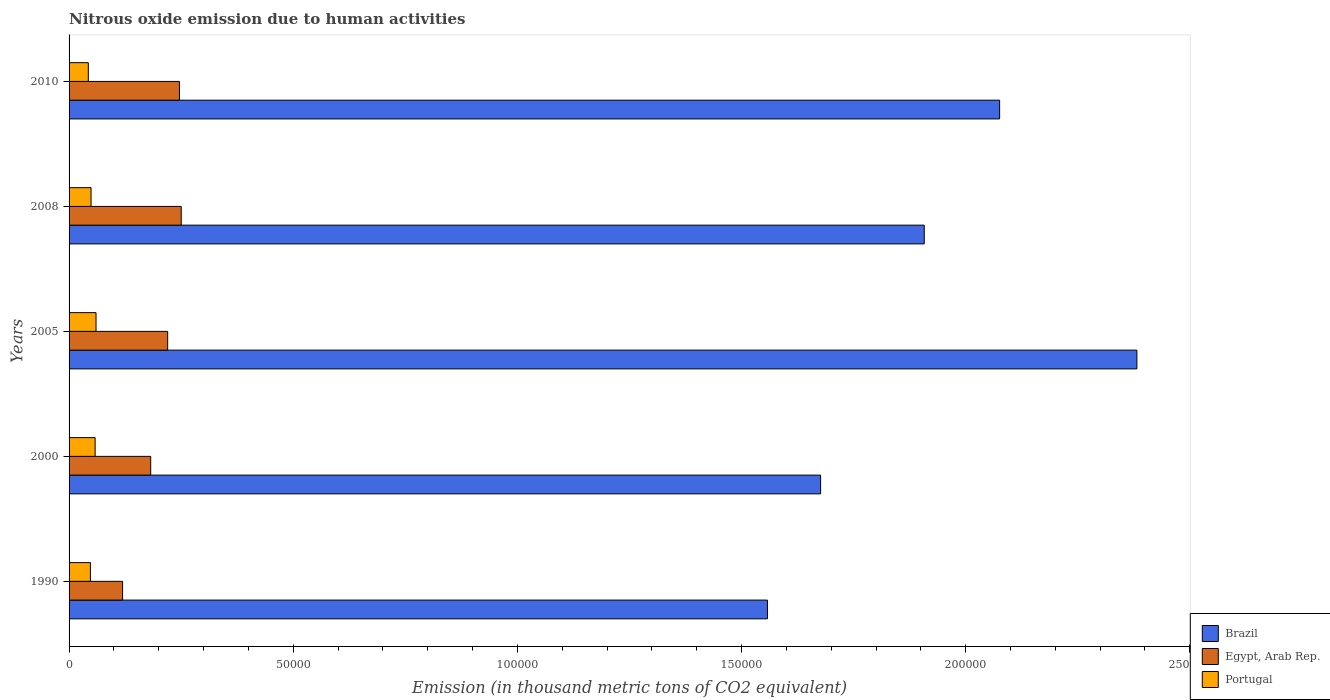Are the number of bars per tick equal to the number of legend labels?
Offer a very short reply. Yes. Are the number of bars on each tick of the Y-axis equal?
Your response must be concise. Yes. How many bars are there on the 4th tick from the bottom?
Your answer should be compact. 3. What is the amount of nitrous oxide emitted in Egypt, Arab Rep. in 2000?
Your answer should be compact. 1.82e+04. Across all years, what is the maximum amount of nitrous oxide emitted in Egypt, Arab Rep.?
Keep it short and to the point. 2.50e+04. Across all years, what is the minimum amount of nitrous oxide emitted in Brazil?
Offer a very short reply. 1.56e+05. In which year was the amount of nitrous oxide emitted in Brazil maximum?
Offer a terse response. 2005. In which year was the amount of nitrous oxide emitted in Brazil minimum?
Your answer should be compact. 1990. What is the total amount of nitrous oxide emitted in Portugal in the graph?
Your answer should be compact. 2.58e+04. What is the difference between the amount of nitrous oxide emitted in Brazil in 1990 and that in 2005?
Give a very brief answer. -8.24e+04. What is the difference between the amount of nitrous oxide emitted in Portugal in 2005 and the amount of nitrous oxide emitted in Egypt, Arab Rep. in 2008?
Ensure brevity in your answer.  -1.90e+04. What is the average amount of nitrous oxide emitted in Egypt, Arab Rep. per year?
Keep it short and to the point. 2.04e+04. In the year 1990, what is the difference between the amount of nitrous oxide emitted in Portugal and amount of nitrous oxide emitted in Egypt, Arab Rep.?
Ensure brevity in your answer.  -7176.1. In how many years, is the amount of nitrous oxide emitted in Portugal greater than 130000 thousand metric tons?
Give a very brief answer. 0. What is the ratio of the amount of nitrous oxide emitted in Portugal in 2005 to that in 2010?
Your response must be concise. 1.4. Is the amount of nitrous oxide emitted in Brazil in 2000 less than that in 2010?
Your answer should be compact. Yes. What is the difference between the highest and the second highest amount of nitrous oxide emitted in Brazil?
Your answer should be very brief. 3.06e+04. What is the difference between the highest and the lowest amount of nitrous oxide emitted in Egypt, Arab Rep.?
Your response must be concise. 1.31e+04. In how many years, is the amount of nitrous oxide emitted in Egypt, Arab Rep. greater than the average amount of nitrous oxide emitted in Egypt, Arab Rep. taken over all years?
Offer a very short reply. 3. Is the sum of the amount of nitrous oxide emitted in Egypt, Arab Rep. in 2008 and 2010 greater than the maximum amount of nitrous oxide emitted in Brazil across all years?
Make the answer very short. No. What does the 3rd bar from the top in 1990 represents?
Your answer should be very brief. Brazil. What does the 1st bar from the bottom in 2005 represents?
Your answer should be compact. Brazil. How many bars are there?
Make the answer very short. 15. Are all the bars in the graph horizontal?
Your response must be concise. Yes. How many years are there in the graph?
Provide a short and direct response. 5. Are the values on the major ticks of X-axis written in scientific E-notation?
Make the answer very short. No. Does the graph contain any zero values?
Make the answer very short. No. How are the legend labels stacked?
Your answer should be compact. Vertical. What is the title of the graph?
Your answer should be very brief. Nitrous oxide emission due to human activities. Does "Papua New Guinea" appear as one of the legend labels in the graph?
Offer a very short reply. No. What is the label or title of the X-axis?
Offer a terse response. Emission (in thousand metric tons of CO2 equivalent). What is the label or title of the Y-axis?
Your response must be concise. Years. What is the Emission (in thousand metric tons of CO2 equivalent) in Brazil in 1990?
Provide a succinct answer. 1.56e+05. What is the Emission (in thousand metric tons of CO2 equivalent) in Egypt, Arab Rep. in 1990?
Your response must be concise. 1.19e+04. What is the Emission (in thousand metric tons of CO2 equivalent) in Portugal in 1990?
Provide a succinct answer. 4760.8. What is the Emission (in thousand metric tons of CO2 equivalent) of Brazil in 2000?
Your answer should be very brief. 1.68e+05. What is the Emission (in thousand metric tons of CO2 equivalent) of Egypt, Arab Rep. in 2000?
Your answer should be very brief. 1.82e+04. What is the Emission (in thousand metric tons of CO2 equivalent) in Portugal in 2000?
Ensure brevity in your answer.  5812.6. What is the Emission (in thousand metric tons of CO2 equivalent) of Brazil in 2005?
Offer a terse response. 2.38e+05. What is the Emission (in thousand metric tons of CO2 equivalent) of Egypt, Arab Rep. in 2005?
Make the answer very short. 2.20e+04. What is the Emission (in thousand metric tons of CO2 equivalent) of Portugal in 2005?
Make the answer very short. 6014.2. What is the Emission (in thousand metric tons of CO2 equivalent) of Brazil in 2008?
Your answer should be very brief. 1.91e+05. What is the Emission (in thousand metric tons of CO2 equivalent) in Egypt, Arab Rep. in 2008?
Provide a succinct answer. 2.50e+04. What is the Emission (in thousand metric tons of CO2 equivalent) in Portugal in 2008?
Provide a short and direct response. 4902.8. What is the Emission (in thousand metric tons of CO2 equivalent) of Brazil in 2010?
Offer a terse response. 2.08e+05. What is the Emission (in thousand metric tons of CO2 equivalent) of Egypt, Arab Rep. in 2010?
Keep it short and to the point. 2.46e+04. What is the Emission (in thousand metric tons of CO2 equivalent) of Portugal in 2010?
Provide a succinct answer. 4291.9. Across all years, what is the maximum Emission (in thousand metric tons of CO2 equivalent) of Brazil?
Your response must be concise. 2.38e+05. Across all years, what is the maximum Emission (in thousand metric tons of CO2 equivalent) of Egypt, Arab Rep.?
Offer a very short reply. 2.50e+04. Across all years, what is the maximum Emission (in thousand metric tons of CO2 equivalent) in Portugal?
Provide a succinct answer. 6014.2. Across all years, what is the minimum Emission (in thousand metric tons of CO2 equivalent) in Brazil?
Offer a terse response. 1.56e+05. Across all years, what is the minimum Emission (in thousand metric tons of CO2 equivalent) in Egypt, Arab Rep.?
Keep it short and to the point. 1.19e+04. Across all years, what is the minimum Emission (in thousand metric tons of CO2 equivalent) in Portugal?
Offer a terse response. 4291.9. What is the total Emission (in thousand metric tons of CO2 equivalent) in Brazil in the graph?
Offer a terse response. 9.60e+05. What is the total Emission (in thousand metric tons of CO2 equivalent) in Egypt, Arab Rep. in the graph?
Ensure brevity in your answer.  1.02e+05. What is the total Emission (in thousand metric tons of CO2 equivalent) of Portugal in the graph?
Give a very brief answer. 2.58e+04. What is the difference between the Emission (in thousand metric tons of CO2 equivalent) in Brazil in 1990 and that in 2000?
Your answer should be very brief. -1.19e+04. What is the difference between the Emission (in thousand metric tons of CO2 equivalent) in Egypt, Arab Rep. in 1990 and that in 2000?
Provide a short and direct response. -6272.2. What is the difference between the Emission (in thousand metric tons of CO2 equivalent) in Portugal in 1990 and that in 2000?
Give a very brief answer. -1051.8. What is the difference between the Emission (in thousand metric tons of CO2 equivalent) of Brazil in 1990 and that in 2005?
Provide a succinct answer. -8.24e+04. What is the difference between the Emission (in thousand metric tons of CO2 equivalent) in Egypt, Arab Rep. in 1990 and that in 2005?
Your response must be concise. -1.01e+04. What is the difference between the Emission (in thousand metric tons of CO2 equivalent) of Portugal in 1990 and that in 2005?
Provide a short and direct response. -1253.4. What is the difference between the Emission (in thousand metric tons of CO2 equivalent) of Brazil in 1990 and that in 2008?
Keep it short and to the point. -3.50e+04. What is the difference between the Emission (in thousand metric tons of CO2 equivalent) in Egypt, Arab Rep. in 1990 and that in 2008?
Offer a very short reply. -1.31e+04. What is the difference between the Emission (in thousand metric tons of CO2 equivalent) in Portugal in 1990 and that in 2008?
Your answer should be compact. -142. What is the difference between the Emission (in thousand metric tons of CO2 equivalent) in Brazil in 1990 and that in 2010?
Offer a terse response. -5.18e+04. What is the difference between the Emission (in thousand metric tons of CO2 equivalent) of Egypt, Arab Rep. in 1990 and that in 2010?
Provide a short and direct response. -1.27e+04. What is the difference between the Emission (in thousand metric tons of CO2 equivalent) of Portugal in 1990 and that in 2010?
Offer a terse response. 468.9. What is the difference between the Emission (in thousand metric tons of CO2 equivalent) in Brazil in 2000 and that in 2005?
Keep it short and to the point. -7.06e+04. What is the difference between the Emission (in thousand metric tons of CO2 equivalent) in Egypt, Arab Rep. in 2000 and that in 2005?
Your response must be concise. -3783.9. What is the difference between the Emission (in thousand metric tons of CO2 equivalent) in Portugal in 2000 and that in 2005?
Make the answer very short. -201.6. What is the difference between the Emission (in thousand metric tons of CO2 equivalent) in Brazil in 2000 and that in 2008?
Your answer should be compact. -2.31e+04. What is the difference between the Emission (in thousand metric tons of CO2 equivalent) in Egypt, Arab Rep. in 2000 and that in 2008?
Your response must be concise. -6806.9. What is the difference between the Emission (in thousand metric tons of CO2 equivalent) in Portugal in 2000 and that in 2008?
Keep it short and to the point. 909.8. What is the difference between the Emission (in thousand metric tons of CO2 equivalent) of Brazil in 2000 and that in 2010?
Your answer should be compact. -3.99e+04. What is the difference between the Emission (in thousand metric tons of CO2 equivalent) in Egypt, Arab Rep. in 2000 and that in 2010?
Ensure brevity in your answer.  -6408.6. What is the difference between the Emission (in thousand metric tons of CO2 equivalent) in Portugal in 2000 and that in 2010?
Your answer should be very brief. 1520.7. What is the difference between the Emission (in thousand metric tons of CO2 equivalent) in Brazil in 2005 and that in 2008?
Your answer should be very brief. 4.74e+04. What is the difference between the Emission (in thousand metric tons of CO2 equivalent) of Egypt, Arab Rep. in 2005 and that in 2008?
Give a very brief answer. -3023. What is the difference between the Emission (in thousand metric tons of CO2 equivalent) of Portugal in 2005 and that in 2008?
Provide a succinct answer. 1111.4. What is the difference between the Emission (in thousand metric tons of CO2 equivalent) of Brazil in 2005 and that in 2010?
Your answer should be compact. 3.06e+04. What is the difference between the Emission (in thousand metric tons of CO2 equivalent) in Egypt, Arab Rep. in 2005 and that in 2010?
Offer a very short reply. -2624.7. What is the difference between the Emission (in thousand metric tons of CO2 equivalent) in Portugal in 2005 and that in 2010?
Provide a succinct answer. 1722.3. What is the difference between the Emission (in thousand metric tons of CO2 equivalent) in Brazil in 2008 and that in 2010?
Ensure brevity in your answer.  -1.68e+04. What is the difference between the Emission (in thousand metric tons of CO2 equivalent) of Egypt, Arab Rep. in 2008 and that in 2010?
Ensure brevity in your answer.  398.3. What is the difference between the Emission (in thousand metric tons of CO2 equivalent) of Portugal in 2008 and that in 2010?
Provide a short and direct response. 610.9. What is the difference between the Emission (in thousand metric tons of CO2 equivalent) in Brazil in 1990 and the Emission (in thousand metric tons of CO2 equivalent) in Egypt, Arab Rep. in 2000?
Your answer should be compact. 1.38e+05. What is the difference between the Emission (in thousand metric tons of CO2 equivalent) in Brazil in 1990 and the Emission (in thousand metric tons of CO2 equivalent) in Portugal in 2000?
Give a very brief answer. 1.50e+05. What is the difference between the Emission (in thousand metric tons of CO2 equivalent) in Egypt, Arab Rep. in 1990 and the Emission (in thousand metric tons of CO2 equivalent) in Portugal in 2000?
Keep it short and to the point. 6124.3. What is the difference between the Emission (in thousand metric tons of CO2 equivalent) in Brazil in 1990 and the Emission (in thousand metric tons of CO2 equivalent) in Egypt, Arab Rep. in 2005?
Your response must be concise. 1.34e+05. What is the difference between the Emission (in thousand metric tons of CO2 equivalent) in Brazil in 1990 and the Emission (in thousand metric tons of CO2 equivalent) in Portugal in 2005?
Offer a terse response. 1.50e+05. What is the difference between the Emission (in thousand metric tons of CO2 equivalent) in Egypt, Arab Rep. in 1990 and the Emission (in thousand metric tons of CO2 equivalent) in Portugal in 2005?
Offer a terse response. 5922.7. What is the difference between the Emission (in thousand metric tons of CO2 equivalent) of Brazil in 1990 and the Emission (in thousand metric tons of CO2 equivalent) of Egypt, Arab Rep. in 2008?
Make the answer very short. 1.31e+05. What is the difference between the Emission (in thousand metric tons of CO2 equivalent) in Brazil in 1990 and the Emission (in thousand metric tons of CO2 equivalent) in Portugal in 2008?
Provide a succinct answer. 1.51e+05. What is the difference between the Emission (in thousand metric tons of CO2 equivalent) of Egypt, Arab Rep. in 1990 and the Emission (in thousand metric tons of CO2 equivalent) of Portugal in 2008?
Keep it short and to the point. 7034.1. What is the difference between the Emission (in thousand metric tons of CO2 equivalent) in Brazil in 1990 and the Emission (in thousand metric tons of CO2 equivalent) in Egypt, Arab Rep. in 2010?
Your answer should be compact. 1.31e+05. What is the difference between the Emission (in thousand metric tons of CO2 equivalent) of Brazil in 1990 and the Emission (in thousand metric tons of CO2 equivalent) of Portugal in 2010?
Give a very brief answer. 1.51e+05. What is the difference between the Emission (in thousand metric tons of CO2 equivalent) of Egypt, Arab Rep. in 1990 and the Emission (in thousand metric tons of CO2 equivalent) of Portugal in 2010?
Your response must be concise. 7645. What is the difference between the Emission (in thousand metric tons of CO2 equivalent) of Brazil in 2000 and the Emission (in thousand metric tons of CO2 equivalent) of Egypt, Arab Rep. in 2005?
Offer a very short reply. 1.46e+05. What is the difference between the Emission (in thousand metric tons of CO2 equivalent) of Brazil in 2000 and the Emission (in thousand metric tons of CO2 equivalent) of Portugal in 2005?
Offer a very short reply. 1.62e+05. What is the difference between the Emission (in thousand metric tons of CO2 equivalent) in Egypt, Arab Rep. in 2000 and the Emission (in thousand metric tons of CO2 equivalent) in Portugal in 2005?
Offer a very short reply. 1.22e+04. What is the difference between the Emission (in thousand metric tons of CO2 equivalent) of Brazil in 2000 and the Emission (in thousand metric tons of CO2 equivalent) of Egypt, Arab Rep. in 2008?
Provide a succinct answer. 1.43e+05. What is the difference between the Emission (in thousand metric tons of CO2 equivalent) in Brazil in 2000 and the Emission (in thousand metric tons of CO2 equivalent) in Portugal in 2008?
Your answer should be compact. 1.63e+05. What is the difference between the Emission (in thousand metric tons of CO2 equivalent) of Egypt, Arab Rep. in 2000 and the Emission (in thousand metric tons of CO2 equivalent) of Portugal in 2008?
Offer a terse response. 1.33e+04. What is the difference between the Emission (in thousand metric tons of CO2 equivalent) in Brazil in 2000 and the Emission (in thousand metric tons of CO2 equivalent) in Egypt, Arab Rep. in 2010?
Provide a short and direct response. 1.43e+05. What is the difference between the Emission (in thousand metric tons of CO2 equivalent) of Brazil in 2000 and the Emission (in thousand metric tons of CO2 equivalent) of Portugal in 2010?
Your answer should be very brief. 1.63e+05. What is the difference between the Emission (in thousand metric tons of CO2 equivalent) of Egypt, Arab Rep. in 2000 and the Emission (in thousand metric tons of CO2 equivalent) of Portugal in 2010?
Offer a very short reply. 1.39e+04. What is the difference between the Emission (in thousand metric tons of CO2 equivalent) in Brazil in 2005 and the Emission (in thousand metric tons of CO2 equivalent) in Egypt, Arab Rep. in 2008?
Your answer should be compact. 2.13e+05. What is the difference between the Emission (in thousand metric tons of CO2 equivalent) in Brazil in 2005 and the Emission (in thousand metric tons of CO2 equivalent) in Portugal in 2008?
Ensure brevity in your answer.  2.33e+05. What is the difference between the Emission (in thousand metric tons of CO2 equivalent) in Egypt, Arab Rep. in 2005 and the Emission (in thousand metric tons of CO2 equivalent) in Portugal in 2008?
Ensure brevity in your answer.  1.71e+04. What is the difference between the Emission (in thousand metric tons of CO2 equivalent) of Brazil in 2005 and the Emission (in thousand metric tons of CO2 equivalent) of Egypt, Arab Rep. in 2010?
Keep it short and to the point. 2.14e+05. What is the difference between the Emission (in thousand metric tons of CO2 equivalent) in Brazil in 2005 and the Emission (in thousand metric tons of CO2 equivalent) in Portugal in 2010?
Ensure brevity in your answer.  2.34e+05. What is the difference between the Emission (in thousand metric tons of CO2 equivalent) of Egypt, Arab Rep. in 2005 and the Emission (in thousand metric tons of CO2 equivalent) of Portugal in 2010?
Your answer should be compact. 1.77e+04. What is the difference between the Emission (in thousand metric tons of CO2 equivalent) of Brazil in 2008 and the Emission (in thousand metric tons of CO2 equivalent) of Egypt, Arab Rep. in 2010?
Keep it short and to the point. 1.66e+05. What is the difference between the Emission (in thousand metric tons of CO2 equivalent) in Brazil in 2008 and the Emission (in thousand metric tons of CO2 equivalent) in Portugal in 2010?
Make the answer very short. 1.86e+05. What is the difference between the Emission (in thousand metric tons of CO2 equivalent) of Egypt, Arab Rep. in 2008 and the Emission (in thousand metric tons of CO2 equivalent) of Portugal in 2010?
Your response must be concise. 2.07e+04. What is the average Emission (in thousand metric tons of CO2 equivalent) in Brazil per year?
Give a very brief answer. 1.92e+05. What is the average Emission (in thousand metric tons of CO2 equivalent) in Egypt, Arab Rep. per year?
Ensure brevity in your answer.  2.04e+04. What is the average Emission (in thousand metric tons of CO2 equivalent) of Portugal per year?
Provide a short and direct response. 5156.46. In the year 1990, what is the difference between the Emission (in thousand metric tons of CO2 equivalent) of Brazil and Emission (in thousand metric tons of CO2 equivalent) of Egypt, Arab Rep.?
Keep it short and to the point. 1.44e+05. In the year 1990, what is the difference between the Emission (in thousand metric tons of CO2 equivalent) in Brazil and Emission (in thousand metric tons of CO2 equivalent) in Portugal?
Offer a terse response. 1.51e+05. In the year 1990, what is the difference between the Emission (in thousand metric tons of CO2 equivalent) of Egypt, Arab Rep. and Emission (in thousand metric tons of CO2 equivalent) of Portugal?
Your response must be concise. 7176.1. In the year 2000, what is the difference between the Emission (in thousand metric tons of CO2 equivalent) in Brazil and Emission (in thousand metric tons of CO2 equivalent) in Egypt, Arab Rep.?
Keep it short and to the point. 1.49e+05. In the year 2000, what is the difference between the Emission (in thousand metric tons of CO2 equivalent) of Brazil and Emission (in thousand metric tons of CO2 equivalent) of Portugal?
Your response must be concise. 1.62e+05. In the year 2000, what is the difference between the Emission (in thousand metric tons of CO2 equivalent) of Egypt, Arab Rep. and Emission (in thousand metric tons of CO2 equivalent) of Portugal?
Ensure brevity in your answer.  1.24e+04. In the year 2005, what is the difference between the Emission (in thousand metric tons of CO2 equivalent) of Brazil and Emission (in thousand metric tons of CO2 equivalent) of Egypt, Arab Rep.?
Provide a short and direct response. 2.16e+05. In the year 2005, what is the difference between the Emission (in thousand metric tons of CO2 equivalent) in Brazil and Emission (in thousand metric tons of CO2 equivalent) in Portugal?
Ensure brevity in your answer.  2.32e+05. In the year 2005, what is the difference between the Emission (in thousand metric tons of CO2 equivalent) of Egypt, Arab Rep. and Emission (in thousand metric tons of CO2 equivalent) of Portugal?
Offer a terse response. 1.60e+04. In the year 2008, what is the difference between the Emission (in thousand metric tons of CO2 equivalent) of Brazil and Emission (in thousand metric tons of CO2 equivalent) of Egypt, Arab Rep.?
Keep it short and to the point. 1.66e+05. In the year 2008, what is the difference between the Emission (in thousand metric tons of CO2 equivalent) in Brazil and Emission (in thousand metric tons of CO2 equivalent) in Portugal?
Provide a succinct answer. 1.86e+05. In the year 2008, what is the difference between the Emission (in thousand metric tons of CO2 equivalent) in Egypt, Arab Rep. and Emission (in thousand metric tons of CO2 equivalent) in Portugal?
Keep it short and to the point. 2.01e+04. In the year 2010, what is the difference between the Emission (in thousand metric tons of CO2 equivalent) of Brazil and Emission (in thousand metric tons of CO2 equivalent) of Egypt, Arab Rep.?
Make the answer very short. 1.83e+05. In the year 2010, what is the difference between the Emission (in thousand metric tons of CO2 equivalent) of Brazil and Emission (in thousand metric tons of CO2 equivalent) of Portugal?
Ensure brevity in your answer.  2.03e+05. In the year 2010, what is the difference between the Emission (in thousand metric tons of CO2 equivalent) in Egypt, Arab Rep. and Emission (in thousand metric tons of CO2 equivalent) in Portugal?
Your response must be concise. 2.03e+04. What is the ratio of the Emission (in thousand metric tons of CO2 equivalent) of Brazil in 1990 to that in 2000?
Provide a succinct answer. 0.93. What is the ratio of the Emission (in thousand metric tons of CO2 equivalent) in Egypt, Arab Rep. in 1990 to that in 2000?
Provide a short and direct response. 0.66. What is the ratio of the Emission (in thousand metric tons of CO2 equivalent) in Portugal in 1990 to that in 2000?
Offer a terse response. 0.82. What is the ratio of the Emission (in thousand metric tons of CO2 equivalent) of Brazil in 1990 to that in 2005?
Provide a succinct answer. 0.65. What is the ratio of the Emission (in thousand metric tons of CO2 equivalent) of Egypt, Arab Rep. in 1990 to that in 2005?
Your answer should be compact. 0.54. What is the ratio of the Emission (in thousand metric tons of CO2 equivalent) in Portugal in 1990 to that in 2005?
Keep it short and to the point. 0.79. What is the ratio of the Emission (in thousand metric tons of CO2 equivalent) in Brazil in 1990 to that in 2008?
Make the answer very short. 0.82. What is the ratio of the Emission (in thousand metric tons of CO2 equivalent) of Egypt, Arab Rep. in 1990 to that in 2008?
Make the answer very short. 0.48. What is the ratio of the Emission (in thousand metric tons of CO2 equivalent) in Portugal in 1990 to that in 2008?
Keep it short and to the point. 0.97. What is the ratio of the Emission (in thousand metric tons of CO2 equivalent) of Brazil in 1990 to that in 2010?
Provide a succinct answer. 0.75. What is the ratio of the Emission (in thousand metric tons of CO2 equivalent) in Egypt, Arab Rep. in 1990 to that in 2010?
Your answer should be very brief. 0.48. What is the ratio of the Emission (in thousand metric tons of CO2 equivalent) in Portugal in 1990 to that in 2010?
Your response must be concise. 1.11. What is the ratio of the Emission (in thousand metric tons of CO2 equivalent) of Brazil in 2000 to that in 2005?
Provide a short and direct response. 0.7. What is the ratio of the Emission (in thousand metric tons of CO2 equivalent) of Egypt, Arab Rep. in 2000 to that in 2005?
Provide a succinct answer. 0.83. What is the ratio of the Emission (in thousand metric tons of CO2 equivalent) in Portugal in 2000 to that in 2005?
Your answer should be compact. 0.97. What is the ratio of the Emission (in thousand metric tons of CO2 equivalent) in Brazil in 2000 to that in 2008?
Your answer should be compact. 0.88. What is the ratio of the Emission (in thousand metric tons of CO2 equivalent) in Egypt, Arab Rep. in 2000 to that in 2008?
Your answer should be compact. 0.73. What is the ratio of the Emission (in thousand metric tons of CO2 equivalent) in Portugal in 2000 to that in 2008?
Provide a short and direct response. 1.19. What is the ratio of the Emission (in thousand metric tons of CO2 equivalent) in Brazil in 2000 to that in 2010?
Provide a succinct answer. 0.81. What is the ratio of the Emission (in thousand metric tons of CO2 equivalent) of Egypt, Arab Rep. in 2000 to that in 2010?
Provide a succinct answer. 0.74. What is the ratio of the Emission (in thousand metric tons of CO2 equivalent) in Portugal in 2000 to that in 2010?
Offer a very short reply. 1.35. What is the ratio of the Emission (in thousand metric tons of CO2 equivalent) of Brazil in 2005 to that in 2008?
Make the answer very short. 1.25. What is the ratio of the Emission (in thousand metric tons of CO2 equivalent) in Egypt, Arab Rep. in 2005 to that in 2008?
Your answer should be very brief. 0.88. What is the ratio of the Emission (in thousand metric tons of CO2 equivalent) of Portugal in 2005 to that in 2008?
Offer a terse response. 1.23. What is the ratio of the Emission (in thousand metric tons of CO2 equivalent) in Brazil in 2005 to that in 2010?
Make the answer very short. 1.15. What is the ratio of the Emission (in thousand metric tons of CO2 equivalent) of Egypt, Arab Rep. in 2005 to that in 2010?
Keep it short and to the point. 0.89. What is the ratio of the Emission (in thousand metric tons of CO2 equivalent) in Portugal in 2005 to that in 2010?
Your response must be concise. 1.4. What is the ratio of the Emission (in thousand metric tons of CO2 equivalent) of Brazil in 2008 to that in 2010?
Keep it short and to the point. 0.92. What is the ratio of the Emission (in thousand metric tons of CO2 equivalent) in Egypt, Arab Rep. in 2008 to that in 2010?
Your answer should be compact. 1.02. What is the ratio of the Emission (in thousand metric tons of CO2 equivalent) in Portugal in 2008 to that in 2010?
Make the answer very short. 1.14. What is the difference between the highest and the second highest Emission (in thousand metric tons of CO2 equivalent) in Brazil?
Offer a very short reply. 3.06e+04. What is the difference between the highest and the second highest Emission (in thousand metric tons of CO2 equivalent) in Egypt, Arab Rep.?
Provide a succinct answer. 398.3. What is the difference between the highest and the second highest Emission (in thousand metric tons of CO2 equivalent) in Portugal?
Keep it short and to the point. 201.6. What is the difference between the highest and the lowest Emission (in thousand metric tons of CO2 equivalent) in Brazil?
Offer a terse response. 8.24e+04. What is the difference between the highest and the lowest Emission (in thousand metric tons of CO2 equivalent) of Egypt, Arab Rep.?
Your response must be concise. 1.31e+04. What is the difference between the highest and the lowest Emission (in thousand metric tons of CO2 equivalent) of Portugal?
Provide a short and direct response. 1722.3. 